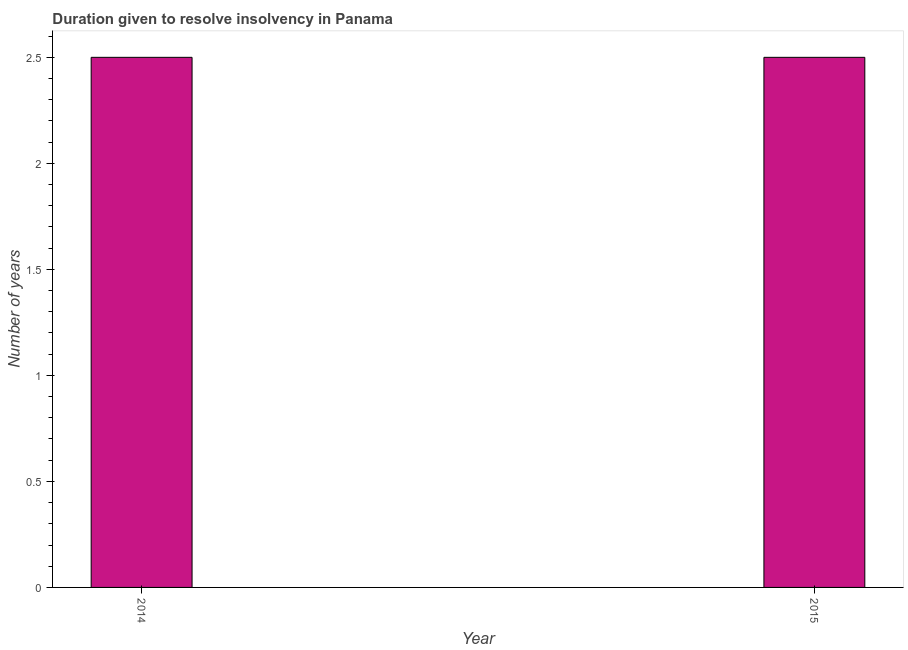What is the title of the graph?
Offer a very short reply. Duration given to resolve insolvency in Panama. What is the label or title of the X-axis?
Make the answer very short. Year. What is the label or title of the Y-axis?
Your answer should be compact. Number of years. What is the number of years to resolve insolvency in 2014?
Provide a short and direct response. 2.5. Across all years, what is the minimum number of years to resolve insolvency?
Your answer should be very brief. 2.5. In which year was the number of years to resolve insolvency maximum?
Offer a very short reply. 2014. In which year was the number of years to resolve insolvency minimum?
Make the answer very short. 2014. What is the sum of the number of years to resolve insolvency?
Keep it short and to the point. 5. What is the difference between the number of years to resolve insolvency in 2014 and 2015?
Provide a succinct answer. 0. What is the median number of years to resolve insolvency?
Provide a succinct answer. 2.5. Do a majority of the years between 2015 and 2014 (inclusive) have number of years to resolve insolvency greater than 1.6 ?
Your response must be concise. No. In how many years, is the number of years to resolve insolvency greater than the average number of years to resolve insolvency taken over all years?
Your answer should be very brief. 0. How many years are there in the graph?
Provide a short and direct response. 2. Are the values on the major ticks of Y-axis written in scientific E-notation?
Keep it short and to the point. No. What is the Number of years of 2014?
Provide a short and direct response. 2.5. What is the difference between the Number of years in 2014 and 2015?
Offer a very short reply. 0. 